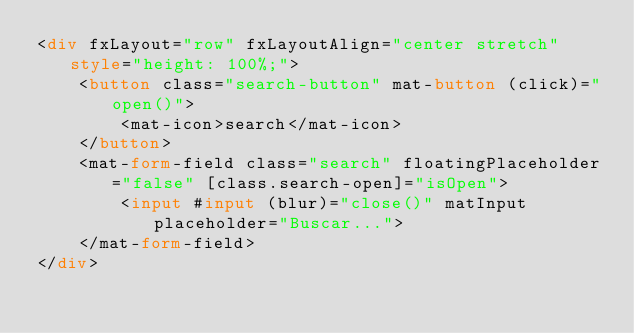Convert code to text. <code><loc_0><loc_0><loc_500><loc_500><_HTML_><div fxLayout="row" fxLayoutAlign="center stretch" style="height: 100%;">
    <button class="search-button" mat-button (click)="open()">
        <mat-icon>search</mat-icon>
    </button>
    <mat-form-field class="search" floatingPlaceholder="false" [class.search-open]="isOpen">
        <input #input (blur)="close()" matInput placeholder="Buscar...">
    </mat-form-field>
</div>
</code> 